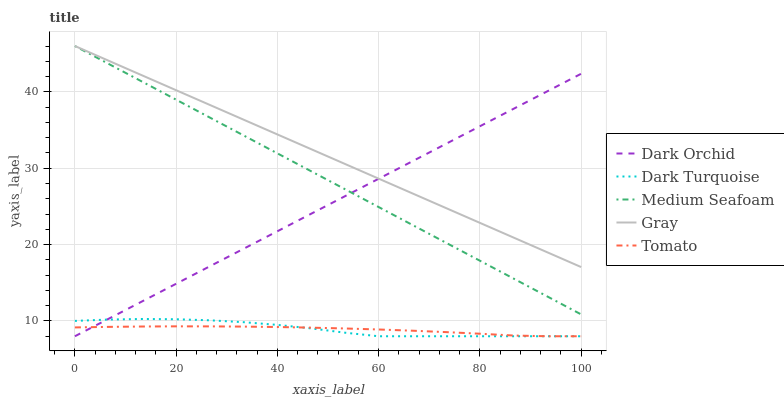Does Tomato have the minimum area under the curve?
Answer yes or no. Yes. Does Gray have the maximum area under the curve?
Answer yes or no. Yes. Does Dark Turquoise have the minimum area under the curve?
Answer yes or no. No. Does Dark Turquoise have the maximum area under the curve?
Answer yes or no. No. Is Dark Orchid the smoothest?
Answer yes or no. Yes. Is Dark Turquoise the roughest?
Answer yes or no. Yes. Is Medium Seafoam the smoothest?
Answer yes or no. No. Is Medium Seafoam the roughest?
Answer yes or no. No. Does Medium Seafoam have the lowest value?
Answer yes or no. No. Does Gray have the highest value?
Answer yes or no. Yes. Does Dark Turquoise have the highest value?
Answer yes or no. No. Is Dark Turquoise less than Gray?
Answer yes or no. Yes. Is Medium Seafoam greater than Tomato?
Answer yes or no. Yes. Does Tomato intersect Dark Turquoise?
Answer yes or no. Yes. Is Tomato less than Dark Turquoise?
Answer yes or no. No. Is Tomato greater than Dark Turquoise?
Answer yes or no. No. Does Dark Turquoise intersect Gray?
Answer yes or no. No. 